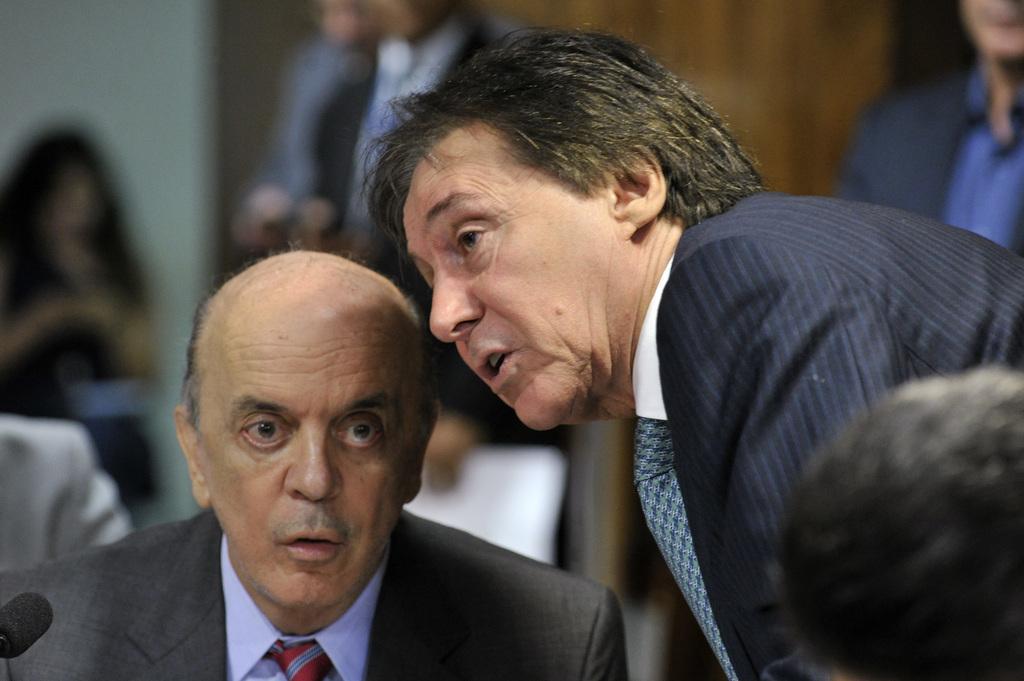Please provide a concise description of this image. In this image we can see a few people, among them some are sitting and some are standing, also we can see a mic and the background is blurred. 